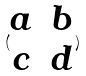Convert formula to latex. <formula><loc_0><loc_0><loc_500><loc_500>( \begin{matrix} a & b \\ c & d \end{matrix} )</formula> 